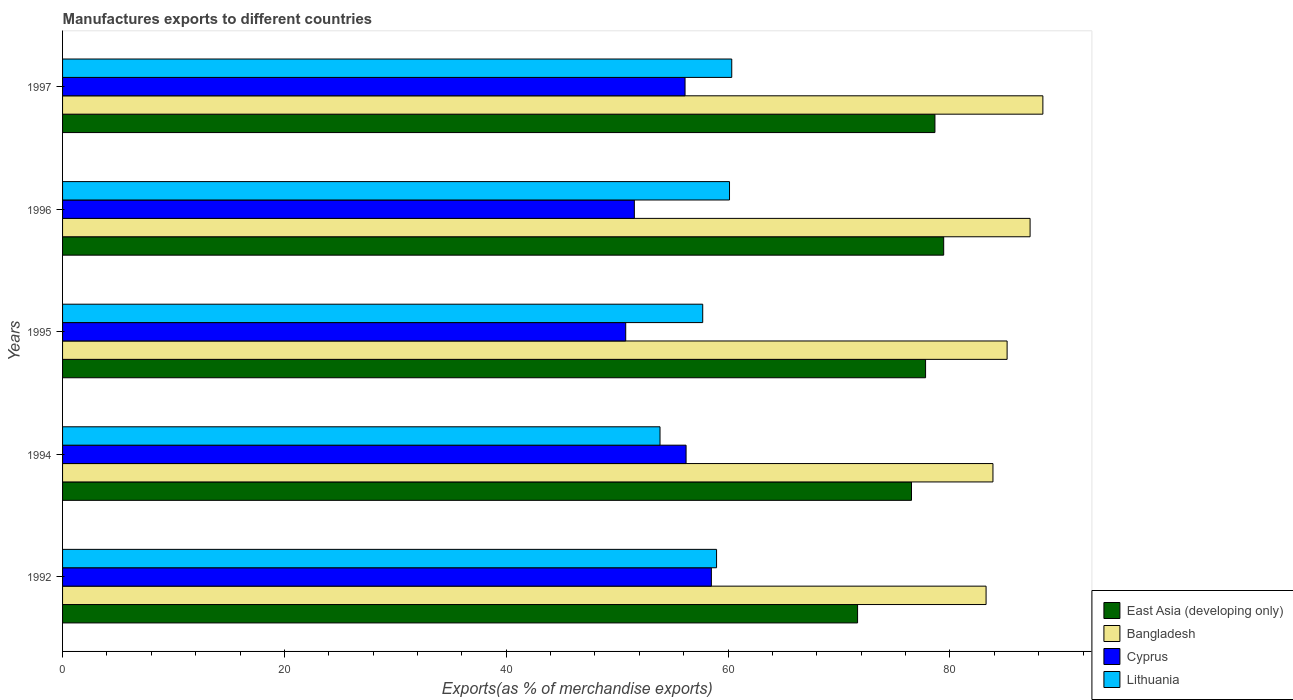How many different coloured bars are there?
Provide a short and direct response. 4. How many groups of bars are there?
Ensure brevity in your answer.  5. What is the label of the 2nd group of bars from the top?
Offer a very short reply. 1996. What is the percentage of exports to different countries in Cyprus in 1992?
Your answer should be compact. 58.49. Across all years, what is the maximum percentage of exports to different countries in Lithuania?
Provide a short and direct response. 60.33. Across all years, what is the minimum percentage of exports to different countries in East Asia (developing only)?
Your answer should be very brief. 71.67. In which year was the percentage of exports to different countries in East Asia (developing only) minimum?
Offer a terse response. 1992. What is the total percentage of exports to different countries in Cyprus in the graph?
Offer a terse response. 273.14. What is the difference between the percentage of exports to different countries in Cyprus in 1992 and that in 1994?
Your answer should be compact. 2.28. What is the difference between the percentage of exports to different countries in Lithuania in 1992 and the percentage of exports to different countries in East Asia (developing only) in 1997?
Provide a succinct answer. -19.69. What is the average percentage of exports to different countries in Bangladesh per year?
Ensure brevity in your answer.  85.58. In the year 1997, what is the difference between the percentage of exports to different countries in Cyprus and percentage of exports to different countries in Bangladesh?
Provide a short and direct response. -32.26. What is the ratio of the percentage of exports to different countries in Cyprus in 1995 to that in 1996?
Provide a short and direct response. 0.98. Is the percentage of exports to different countries in Bangladesh in 1992 less than that in 1997?
Provide a short and direct response. Yes. Is the difference between the percentage of exports to different countries in Cyprus in 1992 and 1996 greater than the difference between the percentage of exports to different countries in Bangladesh in 1992 and 1996?
Provide a short and direct response. Yes. What is the difference between the highest and the second highest percentage of exports to different countries in Lithuania?
Keep it short and to the point. 0.2. What is the difference between the highest and the lowest percentage of exports to different countries in East Asia (developing only)?
Your response must be concise. 7.76. Is the sum of the percentage of exports to different countries in Bangladesh in 1992 and 1995 greater than the maximum percentage of exports to different countries in Cyprus across all years?
Give a very brief answer. Yes. Is it the case that in every year, the sum of the percentage of exports to different countries in Cyprus and percentage of exports to different countries in Lithuania is greater than the sum of percentage of exports to different countries in Bangladesh and percentage of exports to different countries in East Asia (developing only)?
Your response must be concise. No. What does the 4th bar from the top in 1996 represents?
Provide a succinct answer. East Asia (developing only). What does the 1st bar from the bottom in 1996 represents?
Make the answer very short. East Asia (developing only). Is it the case that in every year, the sum of the percentage of exports to different countries in Cyprus and percentage of exports to different countries in East Asia (developing only) is greater than the percentage of exports to different countries in Bangladesh?
Your answer should be compact. Yes. Are all the bars in the graph horizontal?
Your answer should be very brief. Yes. How many years are there in the graph?
Offer a very short reply. 5. Does the graph contain any zero values?
Your answer should be very brief. No. How many legend labels are there?
Offer a very short reply. 4. What is the title of the graph?
Your answer should be compact. Manufactures exports to different countries. What is the label or title of the X-axis?
Your response must be concise. Exports(as % of merchandise exports). What is the label or title of the Y-axis?
Make the answer very short. Years. What is the Exports(as % of merchandise exports) of East Asia (developing only) in 1992?
Your answer should be compact. 71.67. What is the Exports(as % of merchandise exports) in Bangladesh in 1992?
Make the answer very short. 83.26. What is the Exports(as % of merchandise exports) of Cyprus in 1992?
Give a very brief answer. 58.49. What is the Exports(as % of merchandise exports) in Lithuania in 1992?
Give a very brief answer. 58.96. What is the Exports(as % of merchandise exports) of East Asia (developing only) in 1994?
Provide a succinct answer. 76.54. What is the Exports(as % of merchandise exports) of Bangladesh in 1994?
Provide a succinct answer. 83.88. What is the Exports(as % of merchandise exports) in Cyprus in 1994?
Your answer should be compact. 56.21. What is the Exports(as % of merchandise exports) of Lithuania in 1994?
Provide a succinct answer. 53.86. What is the Exports(as % of merchandise exports) in East Asia (developing only) in 1995?
Your response must be concise. 77.8. What is the Exports(as % of merchandise exports) in Bangladesh in 1995?
Make the answer very short. 85.15. What is the Exports(as % of merchandise exports) in Cyprus in 1995?
Give a very brief answer. 50.77. What is the Exports(as % of merchandise exports) of Lithuania in 1995?
Provide a succinct answer. 57.71. What is the Exports(as % of merchandise exports) of East Asia (developing only) in 1996?
Offer a terse response. 79.44. What is the Exports(as % of merchandise exports) in Bangladesh in 1996?
Provide a succinct answer. 87.23. What is the Exports(as % of merchandise exports) in Cyprus in 1996?
Your response must be concise. 51.55. What is the Exports(as % of merchandise exports) in Lithuania in 1996?
Your answer should be compact. 60.13. What is the Exports(as % of merchandise exports) in East Asia (developing only) in 1997?
Your response must be concise. 78.65. What is the Exports(as % of merchandise exports) in Bangladesh in 1997?
Offer a terse response. 88.38. What is the Exports(as % of merchandise exports) of Cyprus in 1997?
Provide a succinct answer. 56.12. What is the Exports(as % of merchandise exports) in Lithuania in 1997?
Make the answer very short. 60.33. Across all years, what is the maximum Exports(as % of merchandise exports) in East Asia (developing only)?
Your answer should be compact. 79.44. Across all years, what is the maximum Exports(as % of merchandise exports) of Bangladesh?
Your answer should be very brief. 88.38. Across all years, what is the maximum Exports(as % of merchandise exports) of Cyprus?
Give a very brief answer. 58.49. Across all years, what is the maximum Exports(as % of merchandise exports) in Lithuania?
Offer a terse response. 60.33. Across all years, what is the minimum Exports(as % of merchandise exports) in East Asia (developing only)?
Give a very brief answer. 71.67. Across all years, what is the minimum Exports(as % of merchandise exports) in Bangladesh?
Keep it short and to the point. 83.26. Across all years, what is the minimum Exports(as % of merchandise exports) in Cyprus?
Your response must be concise. 50.77. Across all years, what is the minimum Exports(as % of merchandise exports) in Lithuania?
Make the answer very short. 53.86. What is the total Exports(as % of merchandise exports) in East Asia (developing only) in the graph?
Your response must be concise. 384.1. What is the total Exports(as % of merchandise exports) of Bangladesh in the graph?
Make the answer very short. 427.9. What is the total Exports(as % of merchandise exports) of Cyprus in the graph?
Your answer should be very brief. 273.14. What is the total Exports(as % of merchandise exports) of Lithuania in the graph?
Provide a short and direct response. 290.99. What is the difference between the Exports(as % of merchandise exports) of East Asia (developing only) in 1992 and that in 1994?
Keep it short and to the point. -4.86. What is the difference between the Exports(as % of merchandise exports) in Bangladesh in 1992 and that in 1994?
Your answer should be very brief. -0.62. What is the difference between the Exports(as % of merchandise exports) of Cyprus in 1992 and that in 1994?
Offer a very short reply. 2.28. What is the difference between the Exports(as % of merchandise exports) of Lithuania in 1992 and that in 1994?
Your response must be concise. 5.1. What is the difference between the Exports(as % of merchandise exports) of East Asia (developing only) in 1992 and that in 1995?
Offer a terse response. -6.13. What is the difference between the Exports(as % of merchandise exports) of Bangladesh in 1992 and that in 1995?
Offer a terse response. -1.9. What is the difference between the Exports(as % of merchandise exports) of Cyprus in 1992 and that in 1995?
Offer a very short reply. 7.72. What is the difference between the Exports(as % of merchandise exports) in Lithuania in 1992 and that in 1995?
Offer a very short reply. 1.25. What is the difference between the Exports(as % of merchandise exports) in East Asia (developing only) in 1992 and that in 1996?
Offer a terse response. -7.76. What is the difference between the Exports(as % of merchandise exports) in Bangladesh in 1992 and that in 1996?
Your response must be concise. -3.97. What is the difference between the Exports(as % of merchandise exports) of Cyprus in 1992 and that in 1996?
Your response must be concise. 6.94. What is the difference between the Exports(as % of merchandise exports) of Lithuania in 1992 and that in 1996?
Provide a short and direct response. -1.17. What is the difference between the Exports(as % of merchandise exports) of East Asia (developing only) in 1992 and that in 1997?
Provide a short and direct response. -6.97. What is the difference between the Exports(as % of merchandise exports) of Bangladesh in 1992 and that in 1997?
Your response must be concise. -5.12. What is the difference between the Exports(as % of merchandise exports) in Cyprus in 1992 and that in 1997?
Offer a terse response. 2.37. What is the difference between the Exports(as % of merchandise exports) in Lithuania in 1992 and that in 1997?
Give a very brief answer. -1.37. What is the difference between the Exports(as % of merchandise exports) in East Asia (developing only) in 1994 and that in 1995?
Ensure brevity in your answer.  -1.27. What is the difference between the Exports(as % of merchandise exports) of Bangladesh in 1994 and that in 1995?
Make the answer very short. -1.28. What is the difference between the Exports(as % of merchandise exports) in Cyprus in 1994 and that in 1995?
Your response must be concise. 5.44. What is the difference between the Exports(as % of merchandise exports) in Lithuania in 1994 and that in 1995?
Your answer should be compact. -3.85. What is the difference between the Exports(as % of merchandise exports) in East Asia (developing only) in 1994 and that in 1996?
Offer a terse response. -2.9. What is the difference between the Exports(as % of merchandise exports) in Bangladesh in 1994 and that in 1996?
Offer a terse response. -3.35. What is the difference between the Exports(as % of merchandise exports) in Cyprus in 1994 and that in 1996?
Offer a very short reply. 4.66. What is the difference between the Exports(as % of merchandise exports) of Lithuania in 1994 and that in 1996?
Ensure brevity in your answer.  -6.26. What is the difference between the Exports(as % of merchandise exports) in East Asia (developing only) in 1994 and that in 1997?
Your answer should be very brief. -2.11. What is the difference between the Exports(as % of merchandise exports) in Bangladesh in 1994 and that in 1997?
Give a very brief answer. -4.5. What is the difference between the Exports(as % of merchandise exports) in Cyprus in 1994 and that in 1997?
Provide a short and direct response. 0.09. What is the difference between the Exports(as % of merchandise exports) of Lithuania in 1994 and that in 1997?
Your answer should be compact. -6.47. What is the difference between the Exports(as % of merchandise exports) of East Asia (developing only) in 1995 and that in 1996?
Keep it short and to the point. -1.63. What is the difference between the Exports(as % of merchandise exports) in Bangladesh in 1995 and that in 1996?
Ensure brevity in your answer.  -2.07. What is the difference between the Exports(as % of merchandise exports) of Cyprus in 1995 and that in 1996?
Keep it short and to the point. -0.78. What is the difference between the Exports(as % of merchandise exports) in Lithuania in 1995 and that in 1996?
Keep it short and to the point. -2.42. What is the difference between the Exports(as % of merchandise exports) of East Asia (developing only) in 1995 and that in 1997?
Your response must be concise. -0.84. What is the difference between the Exports(as % of merchandise exports) in Bangladesh in 1995 and that in 1997?
Give a very brief answer. -3.23. What is the difference between the Exports(as % of merchandise exports) of Cyprus in 1995 and that in 1997?
Your answer should be very brief. -5.35. What is the difference between the Exports(as % of merchandise exports) of Lithuania in 1995 and that in 1997?
Your answer should be very brief. -2.62. What is the difference between the Exports(as % of merchandise exports) of East Asia (developing only) in 1996 and that in 1997?
Your answer should be very brief. 0.79. What is the difference between the Exports(as % of merchandise exports) of Bangladesh in 1996 and that in 1997?
Provide a succinct answer. -1.15. What is the difference between the Exports(as % of merchandise exports) of Cyprus in 1996 and that in 1997?
Your response must be concise. -4.57. What is the difference between the Exports(as % of merchandise exports) of Lithuania in 1996 and that in 1997?
Your answer should be very brief. -0.2. What is the difference between the Exports(as % of merchandise exports) in East Asia (developing only) in 1992 and the Exports(as % of merchandise exports) in Bangladesh in 1994?
Your answer should be compact. -12.21. What is the difference between the Exports(as % of merchandise exports) of East Asia (developing only) in 1992 and the Exports(as % of merchandise exports) of Cyprus in 1994?
Your response must be concise. 15.46. What is the difference between the Exports(as % of merchandise exports) of East Asia (developing only) in 1992 and the Exports(as % of merchandise exports) of Lithuania in 1994?
Provide a succinct answer. 17.81. What is the difference between the Exports(as % of merchandise exports) of Bangladesh in 1992 and the Exports(as % of merchandise exports) of Cyprus in 1994?
Keep it short and to the point. 27.05. What is the difference between the Exports(as % of merchandise exports) in Bangladesh in 1992 and the Exports(as % of merchandise exports) in Lithuania in 1994?
Offer a very short reply. 29.39. What is the difference between the Exports(as % of merchandise exports) in Cyprus in 1992 and the Exports(as % of merchandise exports) in Lithuania in 1994?
Your answer should be compact. 4.63. What is the difference between the Exports(as % of merchandise exports) of East Asia (developing only) in 1992 and the Exports(as % of merchandise exports) of Bangladesh in 1995?
Offer a terse response. -13.48. What is the difference between the Exports(as % of merchandise exports) of East Asia (developing only) in 1992 and the Exports(as % of merchandise exports) of Cyprus in 1995?
Give a very brief answer. 20.9. What is the difference between the Exports(as % of merchandise exports) of East Asia (developing only) in 1992 and the Exports(as % of merchandise exports) of Lithuania in 1995?
Keep it short and to the point. 13.96. What is the difference between the Exports(as % of merchandise exports) in Bangladesh in 1992 and the Exports(as % of merchandise exports) in Cyprus in 1995?
Provide a succinct answer. 32.49. What is the difference between the Exports(as % of merchandise exports) in Bangladesh in 1992 and the Exports(as % of merchandise exports) in Lithuania in 1995?
Ensure brevity in your answer.  25.55. What is the difference between the Exports(as % of merchandise exports) of Cyprus in 1992 and the Exports(as % of merchandise exports) of Lithuania in 1995?
Offer a very short reply. 0.78. What is the difference between the Exports(as % of merchandise exports) of East Asia (developing only) in 1992 and the Exports(as % of merchandise exports) of Bangladesh in 1996?
Your answer should be very brief. -15.55. What is the difference between the Exports(as % of merchandise exports) in East Asia (developing only) in 1992 and the Exports(as % of merchandise exports) in Cyprus in 1996?
Give a very brief answer. 20.13. What is the difference between the Exports(as % of merchandise exports) of East Asia (developing only) in 1992 and the Exports(as % of merchandise exports) of Lithuania in 1996?
Your answer should be very brief. 11.55. What is the difference between the Exports(as % of merchandise exports) of Bangladesh in 1992 and the Exports(as % of merchandise exports) of Cyprus in 1996?
Provide a succinct answer. 31.71. What is the difference between the Exports(as % of merchandise exports) in Bangladesh in 1992 and the Exports(as % of merchandise exports) in Lithuania in 1996?
Provide a succinct answer. 23.13. What is the difference between the Exports(as % of merchandise exports) of Cyprus in 1992 and the Exports(as % of merchandise exports) of Lithuania in 1996?
Your answer should be very brief. -1.63. What is the difference between the Exports(as % of merchandise exports) in East Asia (developing only) in 1992 and the Exports(as % of merchandise exports) in Bangladesh in 1997?
Make the answer very short. -16.71. What is the difference between the Exports(as % of merchandise exports) in East Asia (developing only) in 1992 and the Exports(as % of merchandise exports) in Cyprus in 1997?
Offer a very short reply. 15.55. What is the difference between the Exports(as % of merchandise exports) of East Asia (developing only) in 1992 and the Exports(as % of merchandise exports) of Lithuania in 1997?
Your answer should be compact. 11.34. What is the difference between the Exports(as % of merchandise exports) in Bangladesh in 1992 and the Exports(as % of merchandise exports) in Cyprus in 1997?
Offer a very short reply. 27.14. What is the difference between the Exports(as % of merchandise exports) in Bangladesh in 1992 and the Exports(as % of merchandise exports) in Lithuania in 1997?
Ensure brevity in your answer.  22.93. What is the difference between the Exports(as % of merchandise exports) in Cyprus in 1992 and the Exports(as % of merchandise exports) in Lithuania in 1997?
Provide a succinct answer. -1.84. What is the difference between the Exports(as % of merchandise exports) of East Asia (developing only) in 1994 and the Exports(as % of merchandise exports) of Bangladesh in 1995?
Make the answer very short. -8.62. What is the difference between the Exports(as % of merchandise exports) in East Asia (developing only) in 1994 and the Exports(as % of merchandise exports) in Cyprus in 1995?
Your answer should be very brief. 25.76. What is the difference between the Exports(as % of merchandise exports) of East Asia (developing only) in 1994 and the Exports(as % of merchandise exports) of Lithuania in 1995?
Your answer should be very brief. 18.82. What is the difference between the Exports(as % of merchandise exports) in Bangladesh in 1994 and the Exports(as % of merchandise exports) in Cyprus in 1995?
Make the answer very short. 33.11. What is the difference between the Exports(as % of merchandise exports) in Bangladesh in 1994 and the Exports(as % of merchandise exports) in Lithuania in 1995?
Provide a succinct answer. 26.17. What is the difference between the Exports(as % of merchandise exports) of Cyprus in 1994 and the Exports(as % of merchandise exports) of Lithuania in 1995?
Ensure brevity in your answer.  -1.5. What is the difference between the Exports(as % of merchandise exports) in East Asia (developing only) in 1994 and the Exports(as % of merchandise exports) in Bangladesh in 1996?
Offer a terse response. -10.69. What is the difference between the Exports(as % of merchandise exports) in East Asia (developing only) in 1994 and the Exports(as % of merchandise exports) in Cyprus in 1996?
Your answer should be compact. 24.99. What is the difference between the Exports(as % of merchandise exports) in East Asia (developing only) in 1994 and the Exports(as % of merchandise exports) in Lithuania in 1996?
Your response must be concise. 16.41. What is the difference between the Exports(as % of merchandise exports) of Bangladesh in 1994 and the Exports(as % of merchandise exports) of Cyprus in 1996?
Keep it short and to the point. 32.33. What is the difference between the Exports(as % of merchandise exports) in Bangladesh in 1994 and the Exports(as % of merchandise exports) in Lithuania in 1996?
Offer a terse response. 23.75. What is the difference between the Exports(as % of merchandise exports) in Cyprus in 1994 and the Exports(as % of merchandise exports) in Lithuania in 1996?
Your response must be concise. -3.92. What is the difference between the Exports(as % of merchandise exports) of East Asia (developing only) in 1994 and the Exports(as % of merchandise exports) of Bangladesh in 1997?
Offer a terse response. -11.84. What is the difference between the Exports(as % of merchandise exports) in East Asia (developing only) in 1994 and the Exports(as % of merchandise exports) in Cyprus in 1997?
Make the answer very short. 20.42. What is the difference between the Exports(as % of merchandise exports) of East Asia (developing only) in 1994 and the Exports(as % of merchandise exports) of Lithuania in 1997?
Your answer should be compact. 16.21. What is the difference between the Exports(as % of merchandise exports) in Bangladesh in 1994 and the Exports(as % of merchandise exports) in Cyprus in 1997?
Provide a short and direct response. 27.76. What is the difference between the Exports(as % of merchandise exports) in Bangladesh in 1994 and the Exports(as % of merchandise exports) in Lithuania in 1997?
Provide a succinct answer. 23.55. What is the difference between the Exports(as % of merchandise exports) in Cyprus in 1994 and the Exports(as % of merchandise exports) in Lithuania in 1997?
Give a very brief answer. -4.12. What is the difference between the Exports(as % of merchandise exports) in East Asia (developing only) in 1995 and the Exports(as % of merchandise exports) in Bangladesh in 1996?
Your answer should be very brief. -9.42. What is the difference between the Exports(as % of merchandise exports) in East Asia (developing only) in 1995 and the Exports(as % of merchandise exports) in Cyprus in 1996?
Provide a short and direct response. 26.26. What is the difference between the Exports(as % of merchandise exports) in East Asia (developing only) in 1995 and the Exports(as % of merchandise exports) in Lithuania in 1996?
Make the answer very short. 17.68. What is the difference between the Exports(as % of merchandise exports) in Bangladesh in 1995 and the Exports(as % of merchandise exports) in Cyprus in 1996?
Provide a short and direct response. 33.61. What is the difference between the Exports(as % of merchandise exports) of Bangladesh in 1995 and the Exports(as % of merchandise exports) of Lithuania in 1996?
Offer a terse response. 25.03. What is the difference between the Exports(as % of merchandise exports) in Cyprus in 1995 and the Exports(as % of merchandise exports) in Lithuania in 1996?
Provide a short and direct response. -9.36. What is the difference between the Exports(as % of merchandise exports) of East Asia (developing only) in 1995 and the Exports(as % of merchandise exports) of Bangladesh in 1997?
Provide a succinct answer. -10.58. What is the difference between the Exports(as % of merchandise exports) in East Asia (developing only) in 1995 and the Exports(as % of merchandise exports) in Cyprus in 1997?
Your answer should be very brief. 21.68. What is the difference between the Exports(as % of merchandise exports) of East Asia (developing only) in 1995 and the Exports(as % of merchandise exports) of Lithuania in 1997?
Offer a very short reply. 17.47. What is the difference between the Exports(as % of merchandise exports) of Bangladesh in 1995 and the Exports(as % of merchandise exports) of Cyprus in 1997?
Keep it short and to the point. 29.03. What is the difference between the Exports(as % of merchandise exports) in Bangladesh in 1995 and the Exports(as % of merchandise exports) in Lithuania in 1997?
Provide a short and direct response. 24.82. What is the difference between the Exports(as % of merchandise exports) in Cyprus in 1995 and the Exports(as % of merchandise exports) in Lithuania in 1997?
Provide a succinct answer. -9.56. What is the difference between the Exports(as % of merchandise exports) in East Asia (developing only) in 1996 and the Exports(as % of merchandise exports) in Bangladesh in 1997?
Your answer should be compact. -8.94. What is the difference between the Exports(as % of merchandise exports) of East Asia (developing only) in 1996 and the Exports(as % of merchandise exports) of Cyprus in 1997?
Offer a terse response. 23.32. What is the difference between the Exports(as % of merchandise exports) in East Asia (developing only) in 1996 and the Exports(as % of merchandise exports) in Lithuania in 1997?
Keep it short and to the point. 19.11. What is the difference between the Exports(as % of merchandise exports) of Bangladesh in 1996 and the Exports(as % of merchandise exports) of Cyprus in 1997?
Provide a succinct answer. 31.11. What is the difference between the Exports(as % of merchandise exports) in Bangladesh in 1996 and the Exports(as % of merchandise exports) in Lithuania in 1997?
Provide a succinct answer. 26.9. What is the difference between the Exports(as % of merchandise exports) in Cyprus in 1996 and the Exports(as % of merchandise exports) in Lithuania in 1997?
Your answer should be very brief. -8.78. What is the average Exports(as % of merchandise exports) of East Asia (developing only) per year?
Your answer should be compact. 76.82. What is the average Exports(as % of merchandise exports) of Bangladesh per year?
Keep it short and to the point. 85.58. What is the average Exports(as % of merchandise exports) of Cyprus per year?
Make the answer very short. 54.63. What is the average Exports(as % of merchandise exports) of Lithuania per year?
Give a very brief answer. 58.2. In the year 1992, what is the difference between the Exports(as % of merchandise exports) of East Asia (developing only) and Exports(as % of merchandise exports) of Bangladesh?
Your answer should be compact. -11.58. In the year 1992, what is the difference between the Exports(as % of merchandise exports) in East Asia (developing only) and Exports(as % of merchandise exports) in Cyprus?
Offer a terse response. 13.18. In the year 1992, what is the difference between the Exports(as % of merchandise exports) of East Asia (developing only) and Exports(as % of merchandise exports) of Lithuania?
Your answer should be compact. 12.71. In the year 1992, what is the difference between the Exports(as % of merchandise exports) in Bangladesh and Exports(as % of merchandise exports) in Cyprus?
Offer a terse response. 24.77. In the year 1992, what is the difference between the Exports(as % of merchandise exports) in Bangladesh and Exports(as % of merchandise exports) in Lithuania?
Make the answer very short. 24.3. In the year 1992, what is the difference between the Exports(as % of merchandise exports) of Cyprus and Exports(as % of merchandise exports) of Lithuania?
Keep it short and to the point. -0.47. In the year 1994, what is the difference between the Exports(as % of merchandise exports) in East Asia (developing only) and Exports(as % of merchandise exports) in Bangladesh?
Ensure brevity in your answer.  -7.34. In the year 1994, what is the difference between the Exports(as % of merchandise exports) of East Asia (developing only) and Exports(as % of merchandise exports) of Cyprus?
Ensure brevity in your answer.  20.32. In the year 1994, what is the difference between the Exports(as % of merchandise exports) of East Asia (developing only) and Exports(as % of merchandise exports) of Lithuania?
Ensure brevity in your answer.  22.67. In the year 1994, what is the difference between the Exports(as % of merchandise exports) of Bangladesh and Exports(as % of merchandise exports) of Cyprus?
Offer a terse response. 27.67. In the year 1994, what is the difference between the Exports(as % of merchandise exports) of Bangladesh and Exports(as % of merchandise exports) of Lithuania?
Ensure brevity in your answer.  30.02. In the year 1994, what is the difference between the Exports(as % of merchandise exports) of Cyprus and Exports(as % of merchandise exports) of Lithuania?
Provide a short and direct response. 2.35. In the year 1995, what is the difference between the Exports(as % of merchandise exports) of East Asia (developing only) and Exports(as % of merchandise exports) of Bangladesh?
Your answer should be very brief. -7.35. In the year 1995, what is the difference between the Exports(as % of merchandise exports) of East Asia (developing only) and Exports(as % of merchandise exports) of Cyprus?
Keep it short and to the point. 27.03. In the year 1995, what is the difference between the Exports(as % of merchandise exports) in East Asia (developing only) and Exports(as % of merchandise exports) in Lithuania?
Provide a short and direct response. 20.09. In the year 1995, what is the difference between the Exports(as % of merchandise exports) in Bangladesh and Exports(as % of merchandise exports) in Cyprus?
Your answer should be compact. 34.38. In the year 1995, what is the difference between the Exports(as % of merchandise exports) of Bangladesh and Exports(as % of merchandise exports) of Lithuania?
Ensure brevity in your answer.  27.44. In the year 1995, what is the difference between the Exports(as % of merchandise exports) of Cyprus and Exports(as % of merchandise exports) of Lithuania?
Ensure brevity in your answer.  -6.94. In the year 1996, what is the difference between the Exports(as % of merchandise exports) in East Asia (developing only) and Exports(as % of merchandise exports) in Bangladesh?
Give a very brief answer. -7.79. In the year 1996, what is the difference between the Exports(as % of merchandise exports) of East Asia (developing only) and Exports(as % of merchandise exports) of Cyprus?
Provide a short and direct response. 27.89. In the year 1996, what is the difference between the Exports(as % of merchandise exports) in East Asia (developing only) and Exports(as % of merchandise exports) in Lithuania?
Offer a very short reply. 19.31. In the year 1996, what is the difference between the Exports(as % of merchandise exports) in Bangladesh and Exports(as % of merchandise exports) in Cyprus?
Make the answer very short. 35.68. In the year 1996, what is the difference between the Exports(as % of merchandise exports) in Bangladesh and Exports(as % of merchandise exports) in Lithuania?
Provide a succinct answer. 27.1. In the year 1996, what is the difference between the Exports(as % of merchandise exports) of Cyprus and Exports(as % of merchandise exports) of Lithuania?
Your answer should be compact. -8.58. In the year 1997, what is the difference between the Exports(as % of merchandise exports) in East Asia (developing only) and Exports(as % of merchandise exports) in Bangladesh?
Offer a terse response. -9.73. In the year 1997, what is the difference between the Exports(as % of merchandise exports) of East Asia (developing only) and Exports(as % of merchandise exports) of Cyprus?
Give a very brief answer. 22.53. In the year 1997, what is the difference between the Exports(as % of merchandise exports) in East Asia (developing only) and Exports(as % of merchandise exports) in Lithuania?
Give a very brief answer. 18.32. In the year 1997, what is the difference between the Exports(as % of merchandise exports) in Bangladesh and Exports(as % of merchandise exports) in Cyprus?
Your answer should be compact. 32.26. In the year 1997, what is the difference between the Exports(as % of merchandise exports) of Bangladesh and Exports(as % of merchandise exports) of Lithuania?
Offer a very short reply. 28.05. In the year 1997, what is the difference between the Exports(as % of merchandise exports) in Cyprus and Exports(as % of merchandise exports) in Lithuania?
Provide a short and direct response. -4.21. What is the ratio of the Exports(as % of merchandise exports) of East Asia (developing only) in 1992 to that in 1994?
Ensure brevity in your answer.  0.94. What is the ratio of the Exports(as % of merchandise exports) in Cyprus in 1992 to that in 1994?
Provide a short and direct response. 1.04. What is the ratio of the Exports(as % of merchandise exports) of Lithuania in 1992 to that in 1994?
Ensure brevity in your answer.  1.09. What is the ratio of the Exports(as % of merchandise exports) in East Asia (developing only) in 1992 to that in 1995?
Provide a short and direct response. 0.92. What is the ratio of the Exports(as % of merchandise exports) of Bangladesh in 1992 to that in 1995?
Your answer should be compact. 0.98. What is the ratio of the Exports(as % of merchandise exports) in Cyprus in 1992 to that in 1995?
Your answer should be compact. 1.15. What is the ratio of the Exports(as % of merchandise exports) of Lithuania in 1992 to that in 1995?
Offer a terse response. 1.02. What is the ratio of the Exports(as % of merchandise exports) in East Asia (developing only) in 1992 to that in 1996?
Your response must be concise. 0.9. What is the ratio of the Exports(as % of merchandise exports) in Bangladesh in 1992 to that in 1996?
Keep it short and to the point. 0.95. What is the ratio of the Exports(as % of merchandise exports) in Cyprus in 1992 to that in 1996?
Your response must be concise. 1.13. What is the ratio of the Exports(as % of merchandise exports) in Lithuania in 1992 to that in 1996?
Keep it short and to the point. 0.98. What is the ratio of the Exports(as % of merchandise exports) of East Asia (developing only) in 1992 to that in 1997?
Your response must be concise. 0.91. What is the ratio of the Exports(as % of merchandise exports) of Bangladesh in 1992 to that in 1997?
Your response must be concise. 0.94. What is the ratio of the Exports(as % of merchandise exports) of Cyprus in 1992 to that in 1997?
Your answer should be compact. 1.04. What is the ratio of the Exports(as % of merchandise exports) of Lithuania in 1992 to that in 1997?
Give a very brief answer. 0.98. What is the ratio of the Exports(as % of merchandise exports) in East Asia (developing only) in 1994 to that in 1995?
Make the answer very short. 0.98. What is the ratio of the Exports(as % of merchandise exports) of Cyprus in 1994 to that in 1995?
Offer a very short reply. 1.11. What is the ratio of the Exports(as % of merchandise exports) in Lithuania in 1994 to that in 1995?
Keep it short and to the point. 0.93. What is the ratio of the Exports(as % of merchandise exports) of East Asia (developing only) in 1994 to that in 1996?
Give a very brief answer. 0.96. What is the ratio of the Exports(as % of merchandise exports) in Bangladesh in 1994 to that in 1996?
Give a very brief answer. 0.96. What is the ratio of the Exports(as % of merchandise exports) of Cyprus in 1994 to that in 1996?
Offer a terse response. 1.09. What is the ratio of the Exports(as % of merchandise exports) of Lithuania in 1994 to that in 1996?
Make the answer very short. 0.9. What is the ratio of the Exports(as % of merchandise exports) in East Asia (developing only) in 1994 to that in 1997?
Provide a short and direct response. 0.97. What is the ratio of the Exports(as % of merchandise exports) of Bangladesh in 1994 to that in 1997?
Provide a succinct answer. 0.95. What is the ratio of the Exports(as % of merchandise exports) in Cyprus in 1994 to that in 1997?
Provide a short and direct response. 1. What is the ratio of the Exports(as % of merchandise exports) in Lithuania in 1994 to that in 1997?
Ensure brevity in your answer.  0.89. What is the ratio of the Exports(as % of merchandise exports) of East Asia (developing only) in 1995 to that in 1996?
Give a very brief answer. 0.98. What is the ratio of the Exports(as % of merchandise exports) of Bangladesh in 1995 to that in 1996?
Give a very brief answer. 0.98. What is the ratio of the Exports(as % of merchandise exports) of Cyprus in 1995 to that in 1996?
Keep it short and to the point. 0.98. What is the ratio of the Exports(as % of merchandise exports) in Lithuania in 1995 to that in 1996?
Provide a succinct answer. 0.96. What is the ratio of the Exports(as % of merchandise exports) of East Asia (developing only) in 1995 to that in 1997?
Provide a succinct answer. 0.99. What is the ratio of the Exports(as % of merchandise exports) in Bangladesh in 1995 to that in 1997?
Give a very brief answer. 0.96. What is the ratio of the Exports(as % of merchandise exports) of Cyprus in 1995 to that in 1997?
Provide a succinct answer. 0.9. What is the ratio of the Exports(as % of merchandise exports) in Lithuania in 1995 to that in 1997?
Provide a short and direct response. 0.96. What is the ratio of the Exports(as % of merchandise exports) of Bangladesh in 1996 to that in 1997?
Give a very brief answer. 0.99. What is the ratio of the Exports(as % of merchandise exports) in Cyprus in 1996 to that in 1997?
Give a very brief answer. 0.92. What is the difference between the highest and the second highest Exports(as % of merchandise exports) of East Asia (developing only)?
Give a very brief answer. 0.79. What is the difference between the highest and the second highest Exports(as % of merchandise exports) of Bangladesh?
Give a very brief answer. 1.15. What is the difference between the highest and the second highest Exports(as % of merchandise exports) of Cyprus?
Provide a short and direct response. 2.28. What is the difference between the highest and the second highest Exports(as % of merchandise exports) of Lithuania?
Your response must be concise. 0.2. What is the difference between the highest and the lowest Exports(as % of merchandise exports) of East Asia (developing only)?
Your answer should be compact. 7.76. What is the difference between the highest and the lowest Exports(as % of merchandise exports) of Bangladesh?
Provide a succinct answer. 5.12. What is the difference between the highest and the lowest Exports(as % of merchandise exports) in Cyprus?
Offer a very short reply. 7.72. What is the difference between the highest and the lowest Exports(as % of merchandise exports) of Lithuania?
Offer a very short reply. 6.47. 